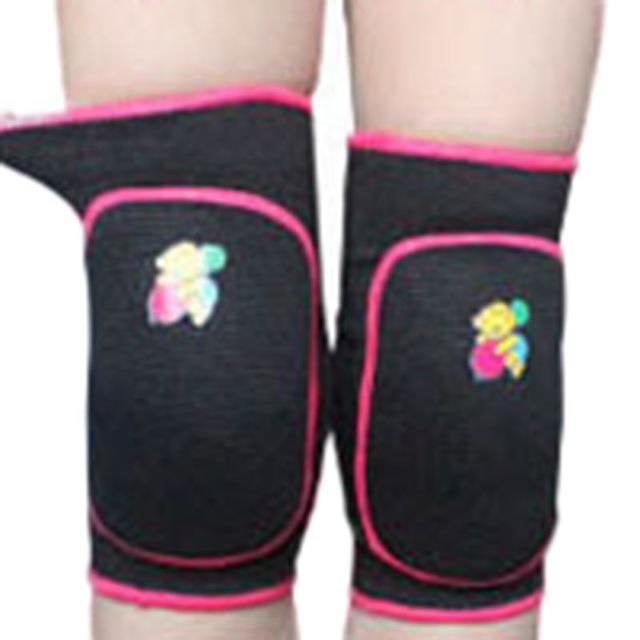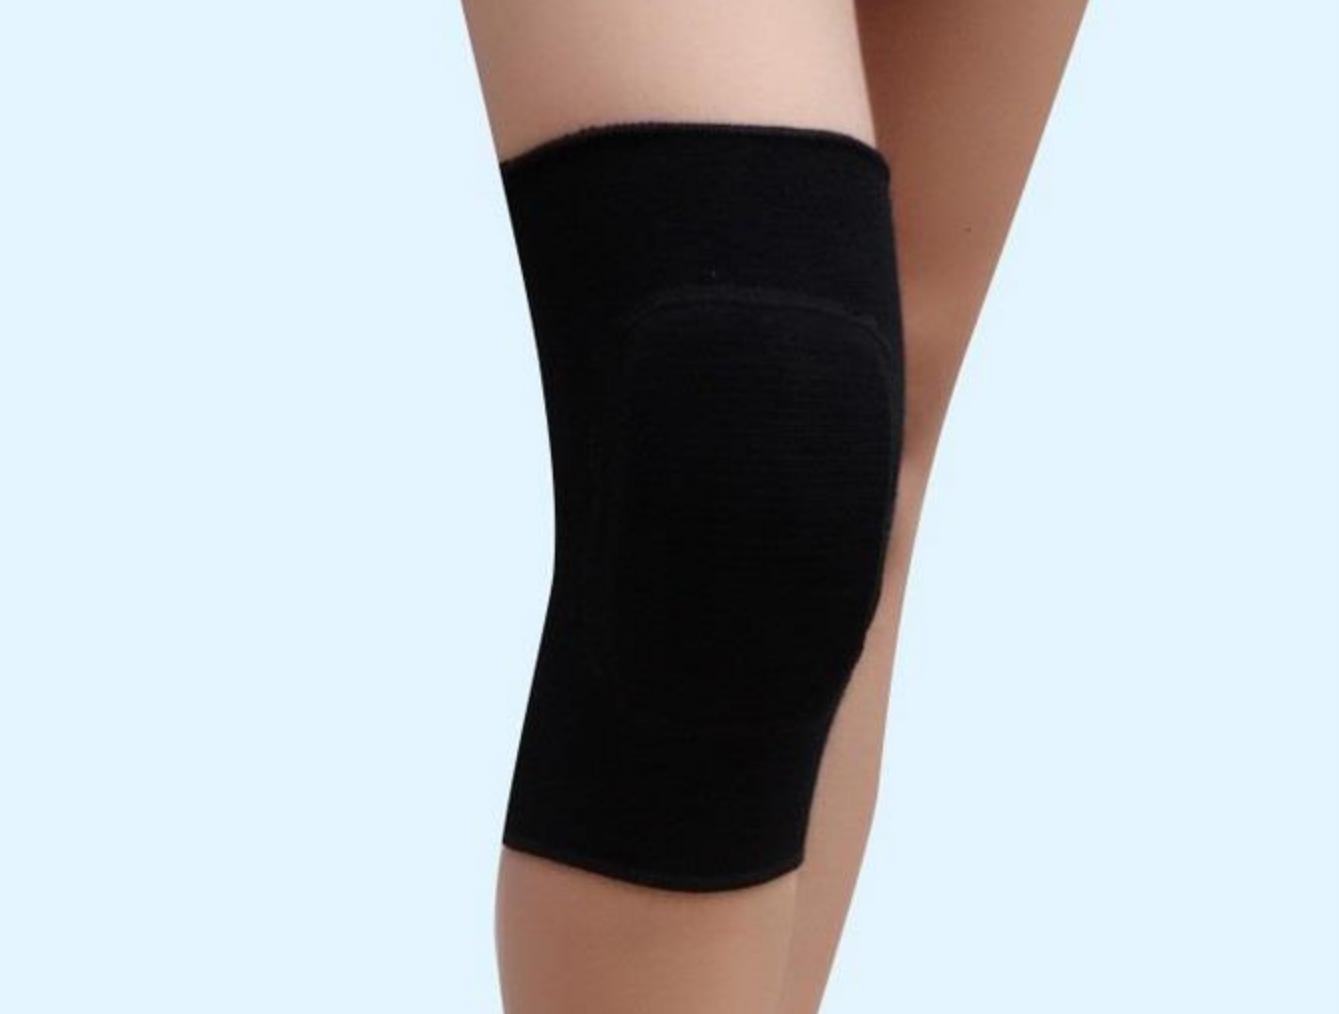The first image is the image on the left, the second image is the image on the right. Given the left and right images, does the statement "Only black kneepads are shown, and the left and right images contain the same number of kneepads." hold true? Answer yes or no. No. The first image is the image on the left, the second image is the image on the right. Considering the images on both sides, is "there is a pair of knee pads with mesh sides and a cut out behind the knee" valid? Answer yes or no. No. 